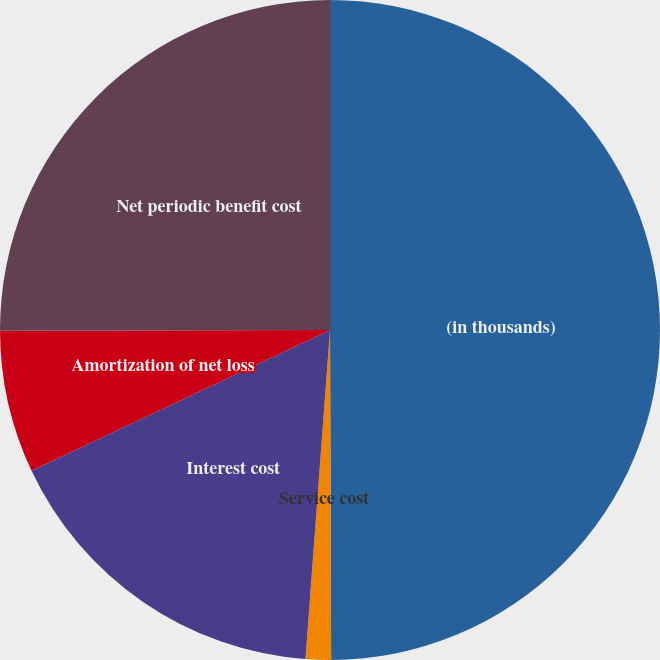Convert chart to OTSL. <chart><loc_0><loc_0><loc_500><loc_500><pie_chart><fcel>(in thousands)<fcel>Service cost<fcel>Interest cost<fcel>Amortization of net loss<fcel>Net periodic benefit cost<nl><fcel>49.94%<fcel>1.24%<fcel>16.8%<fcel>6.98%<fcel>25.03%<nl></chart> 